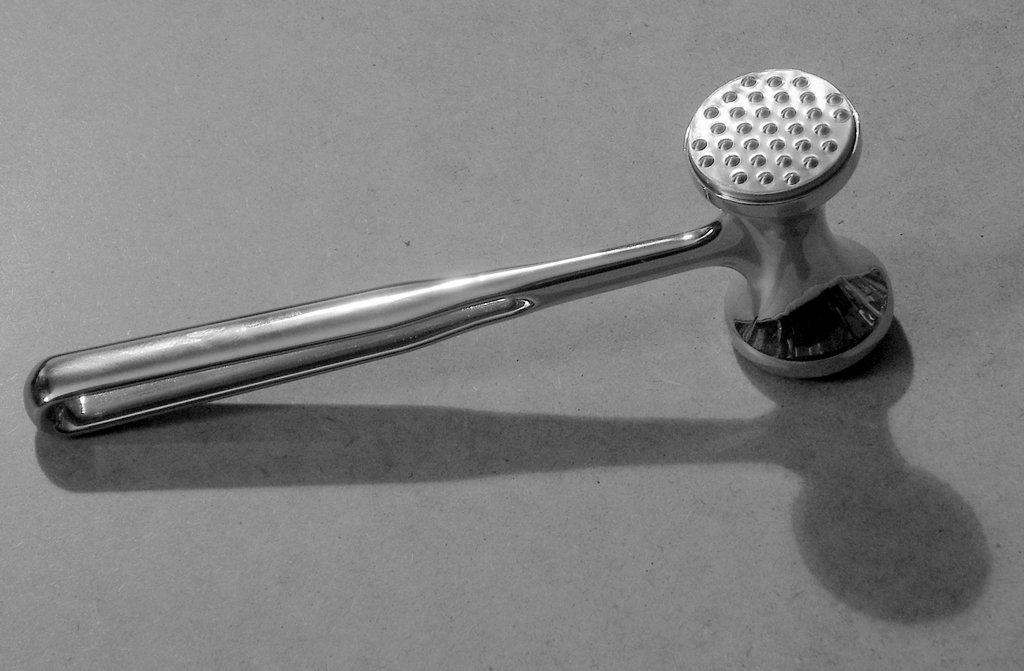What object can be seen in the image? There is a mallet in the image. Where is the mallet located? The mallet is placed on a surface. How many clams are attached to the mallet in the image? There are no clams present in the image; it only features a mallet placed on a surface. 